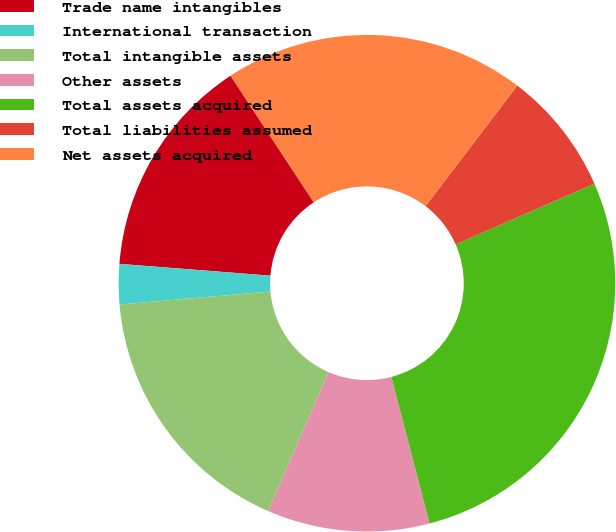Convert chart. <chart><loc_0><loc_0><loc_500><loc_500><pie_chart><fcel>Trade name intangibles<fcel>International transaction<fcel>Total intangible assets<fcel>Other assets<fcel>Total assets acquired<fcel>Total liabilities assumed<fcel>Net assets acquired<nl><fcel>14.5%<fcel>2.61%<fcel>17.12%<fcel>10.57%<fcel>27.51%<fcel>8.08%<fcel>19.61%<nl></chart> 